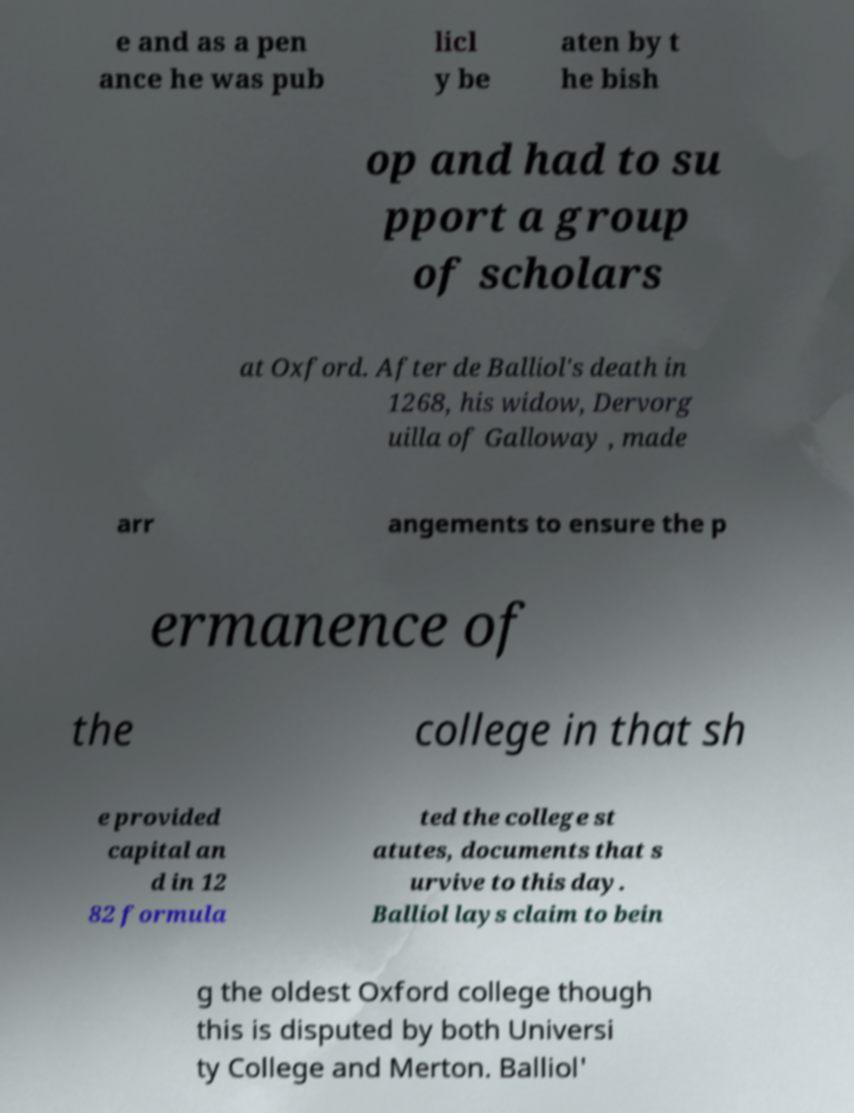Can you accurately transcribe the text from the provided image for me? e and as a pen ance he was pub licl y be aten by t he bish op and had to su pport a group of scholars at Oxford. After de Balliol's death in 1268, his widow, Dervorg uilla of Galloway , made arr angements to ensure the p ermanence of the college in that sh e provided capital an d in 12 82 formula ted the college st atutes, documents that s urvive to this day. Balliol lays claim to bein g the oldest Oxford college though this is disputed by both Universi ty College and Merton. Balliol' 